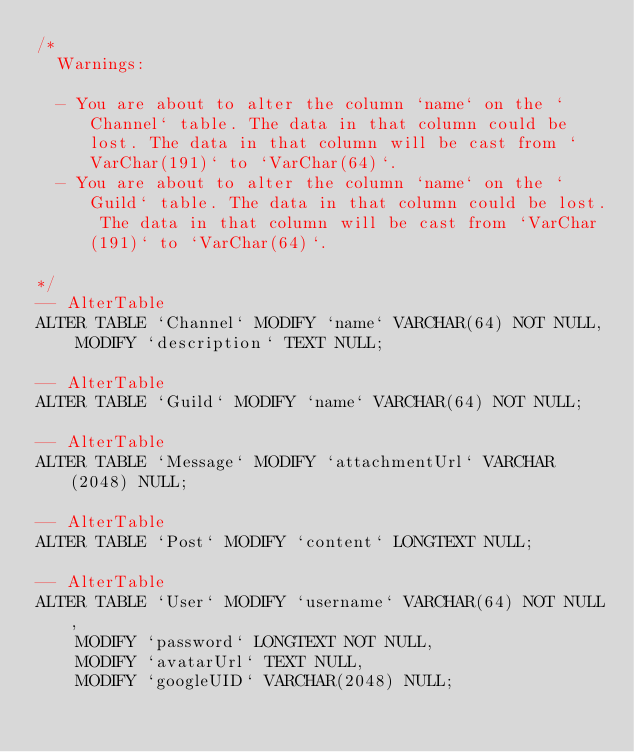<code> <loc_0><loc_0><loc_500><loc_500><_SQL_>/*
  Warnings:

  - You are about to alter the column `name` on the `Channel` table. The data in that column could be lost. The data in that column will be cast from `VarChar(191)` to `VarChar(64)`.
  - You are about to alter the column `name` on the `Guild` table. The data in that column could be lost. The data in that column will be cast from `VarChar(191)` to `VarChar(64)`.

*/
-- AlterTable
ALTER TABLE `Channel` MODIFY `name` VARCHAR(64) NOT NULL,
    MODIFY `description` TEXT NULL;

-- AlterTable
ALTER TABLE `Guild` MODIFY `name` VARCHAR(64) NOT NULL;

-- AlterTable
ALTER TABLE `Message` MODIFY `attachmentUrl` VARCHAR(2048) NULL;

-- AlterTable
ALTER TABLE `Post` MODIFY `content` LONGTEXT NULL;

-- AlterTable
ALTER TABLE `User` MODIFY `username` VARCHAR(64) NOT NULL,
    MODIFY `password` LONGTEXT NOT NULL,
    MODIFY `avatarUrl` TEXT NULL,
    MODIFY `googleUID` VARCHAR(2048) NULL;
</code> 